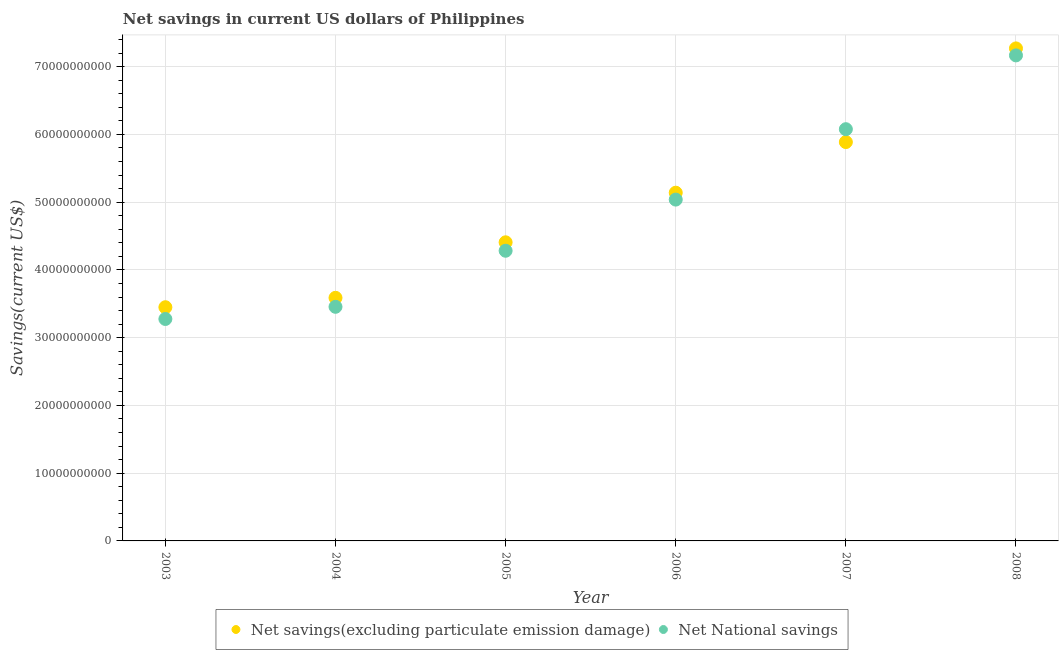How many different coloured dotlines are there?
Your response must be concise. 2. Is the number of dotlines equal to the number of legend labels?
Give a very brief answer. Yes. What is the net savings(excluding particulate emission damage) in 2005?
Provide a short and direct response. 4.41e+1. Across all years, what is the maximum net savings(excluding particulate emission damage)?
Provide a short and direct response. 7.27e+1. Across all years, what is the minimum net savings(excluding particulate emission damage)?
Make the answer very short. 3.45e+1. In which year was the net national savings minimum?
Ensure brevity in your answer.  2003. What is the total net savings(excluding particulate emission damage) in the graph?
Your answer should be compact. 2.97e+11. What is the difference between the net national savings in 2003 and that in 2007?
Provide a short and direct response. -2.80e+1. What is the difference between the net national savings in 2006 and the net savings(excluding particulate emission damage) in 2008?
Ensure brevity in your answer.  -2.23e+1. What is the average net national savings per year?
Offer a terse response. 4.88e+1. In the year 2007, what is the difference between the net national savings and net savings(excluding particulate emission damage)?
Make the answer very short. 1.90e+09. In how many years, is the net savings(excluding particulate emission damage) greater than 14000000000 US$?
Keep it short and to the point. 6. What is the ratio of the net savings(excluding particulate emission damage) in 2005 to that in 2006?
Your answer should be compact. 0.86. Is the difference between the net savings(excluding particulate emission damage) in 2006 and 2008 greater than the difference between the net national savings in 2006 and 2008?
Make the answer very short. No. What is the difference between the highest and the second highest net savings(excluding particulate emission damage)?
Provide a succinct answer. 1.38e+1. What is the difference between the highest and the lowest net savings(excluding particulate emission damage)?
Provide a short and direct response. 3.82e+1. In how many years, is the net savings(excluding particulate emission damage) greater than the average net savings(excluding particulate emission damage) taken over all years?
Your response must be concise. 3. Is the net national savings strictly greater than the net savings(excluding particulate emission damage) over the years?
Your answer should be very brief. No. How many dotlines are there?
Provide a short and direct response. 2. How many years are there in the graph?
Give a very brief answer. 6. What is the difference between two consecutive major ticks on the Y-axis?
Offer a very short reply. 1.00e+1. Where does the legend appear in the graph?
Provide a succinct answer. Bottom center. How are the legend labels stacked?
Provide a short and direct response. Horizontal. What is the title of the graph?
Offer a very short reply. Net savings in current US dollars of Philippines. Does "Public funds" appear as one of the legend labels in the graph?
Your answer should be very brief. No. What is the label or title of the X-axis?
Give a very brief answer. Year. What is the label or title of the Y-axis?
Your answer should be compact. Savings(current US$). What is the Savings(current US$) in Net savings(excluding particulate emission damage) in 2003?
Provide a succinct answer. 3.45e+1. What is the Savings(current US$) in Net National savings in 2003?
Give a very brief answer. 3.28e+1. What is the Savings(current US$) in Net savings(excluding particulate emission damage) in 2004?
Keep it short and to the point. 3.59e+1. What is the Savings(current US$) of Net National savings in 2004?
Give a very brief answer. 3.46e+1. What is the Savings(current US$) of Net savings(excluding particulate emission damage) in 2005?
Your answer should be very brief. 4.41e+1. What is the Savings(current US$) in Net National savings in 2005?
Your answer should be compact. 4.28e+1. What is the Savings(current US$) of Net savings(excluding particulate emission damage) in 2006?
Give a very brief answer. 5.14e+1. What is the Savings(current US$) of Net National savings in 2006?
Your response must be concise. 5.04e+1. What is the Savings(current US$) of Net savings(excluding particulate emission damage) in 2007?
Ensure brevity in your answer.  5.89e+1. What is the Savings(current US$) of Net National savings in 2007?
Keep it short and to the point. 6.08e+1. What is the Savings(current US$) in Net savings(excluding particulate emission damage) in 2008?
Your answer should be very brief. 7.27e+1. What is the Savings(current US$) in Net National savings in 2008?
Offer a very short reply. 7.17e+1. Across all years, what is the maximum Savings(current US$) of Net savings(excluding particulate emission damage)?
Your answer should be compact. 7.27e+1. Across all years, what is the maximum Savings(current US$) in Net National savings?
Your answer should be very brief. 7.17e+1. Across all years, what is the minimum Savings(current US$) of Net savings(excluding particulate emission damage)?
Your response must be concise. 3.45e+1. Across all years, what is the minimum Savings(current US$) of Net National savings?
Make the answer very short. 3.28e+1. What is the total Savings(current US$) of Net savings(excluding particulate emission damage) in the graph?
Offer a terse response. 2.97e+11. What is the total Savings(current US$) in Net National savings in the graph?
Your answer should be compact. 2.93e+11. What is the difference between the Savings(current US$) of Net savings(excluding particulate emission damage) in 2003 and that in 2004?
Offer a very short reply. -1.39e+09. What is the difference between the Savings(current US$) in Net National savings in 2003 and that in 2004?
Offer a terse response. -1.80e+09. What is the difference between the Savings(current US$) of Net savings(excluding particulate emission damage) in 2003 and that in 2005?
Your answer should be compact. -9.58e+09. What is the difference between the Savings(current US$) of Net National savings in 2003 and that in 2005?
Ensure brevity in your answer.  -1.01e+1. What is the difference between the Savings(current US$) in Net savings(excluding particulate emission damage) in 2003 and that in 2006?
Offer a terse response. -1.69e+1. What is the difference between the Savings(current US$) in Net National savings in 2003 and that in 2006?
Offer a terse response. -1.76e+1. What is the difference between the Savings(current US$) of Net savings(excluding particulate emission damage) in 2003 and that in 2007?
Make the answer very short. -2.44e+1. What is the difference between the Savings(current US$) of Net National savings in 2003 and that in 2007?
Your answer should be compact. -2.80e+1. What is the difference between the Savings(current US$) in Net savings(excluding particulate emission damage) in 2003 and that in 2008?
Ensure brevity in your answer.  -3.82e+1. What is the difference between the Savings(current US$) of Net National savings in 2003 and that in 2008?
Ensure brevity in your answer.  -3.89e+1. What is the difference between the Savings(current US$) in Net savings(excluding particulate emission damage) in 2004 and that in 2005?
Your answer should be very brief. -8.19e+09. What is the difference between the Savings(current US$) of Net National savings in 2004 and that in 2005?
Give a very brief answer. -8.27e+09. What is the difference between the Savings(current US$) of Net savings(excluding particulate emission damage) in 2004 and that in 2006?
Offer a very short reply. -1.55e+1. What is the difference between the Savings(current US$) of Net National savings in 2004 and that in 2006?
Ensure brevity in your answer.  -1.58e+1. What is the difference between the Savings(current US$) of Net savings(excluding particulate emission damage) in 2004 and that in 2007?
Ensure brevity in your answer.  -2.30e+1. What is the difference between the Savings(current US$) in Net National savings in 2004 and that in 2007?
Give a very brief answer. -2.62e+1. What is the difference between the Savings(current US$) in Net savings(excluding particulate emission damage) in 2004 and that in 2008?
Give a very brief answer. -3.68e+1. What is the difference between the Savings(current US$) in Net National savings in 2004 and that in 2008?
Your response must be concise. -3.71e+1. What is the difference between the Savings(current US$) in Net savings(excluding particulate emission damage) in 2005 and that in 2006?
Your answer should be compact. -7.32e+09. What is the difference between the Savings(current US$) of Net National savings in 2005 and that in 2006?
Keep it short and to the point. -7.55e+09. What is the difference between the Savings(current US$) in Net savings(excluding particulate emission damage) in 2005 and that in 2007?
Give a very brief answer. -1.48e+1. What is the difference between the Savings(current US$) of Net National savings in 2005 and that in 2007?
Make the answer very short. -1.79e+1. What is the difference between the Savings(current US$) of Net savings(excluding particulate emission damage) in 2005 and that in 2008?
Your answer should be compact. -2.86e+1. What is the difference between the Savings(current US$) of Net National savings in 2005 and that in 2008?
Give a very brief answer. -2.88e+1. What is the difference between the Savings(current US$) in Net savings(excluding particulate emission damage) in 2006 and that in 2007?
Offer a terse response. -7.47e+09. What is the difference between the Savings(current US$) in Net National savings in 2006 and that in 2007?
Keep it short and to the point. -1.04e+1. What is the difference between the Savings(current US$) of Net savings(excluding particulate emission damage) in 2006 and that in 2008?
Give a very brief answer. -2.13e+1. What is the difference between the Savings(current US$) of Net National savings in 2006 and that in 2008?
Your answer should be very brief. -2.13e+1. What is the difference between the Savings(current US$) of Net savings(excluding particulate emission damage) in 2007 and that in 2008?
Your response must be concise. -1.38e+1. What is the difference between the Savings(current US$) in Net National savings in 2007 and that in 2008?
Your response must be concise. -1.09e+1. What is the difference between the Savings(current US$) in Net savings(excluding particulate emission damage) in 2003 and the Savings(current US$) in Net National savings in 2004?
Your response must be concise. -6.26e+07. What is the difference between the Savings(current US$) in Net savings(excluding particulate emission damage) in 2003 and the Savings(current US$) in Net National savings in 2005?
Provide a succinct answer. -8.34e+09. What is the difference between the Savings(current US$) of Net savings(excluding particulate emission damage) in 2003 and the Savings(current US$) of Net National savings in 2006?
Provide a short and direct response. -1.59e+1. What is the difference between the Savings(current US$) of Net savings(excluding particulate emission damage) in 2003 and the Savings(current US$) of Net National savings in 2007?
Give a very brief answer. -2.63e+1. What is the difference between the Savings(current US$) of Net savings(excluding particulate emission damage) in 2003 and the Savings(current US$) of Net National savings in 2008?
Provide a succinct answer. -3.72e+1. What is the difference between the Savings(current US$) of Net savings(excluding particulate emission damage) in 2004 and the Savings(current US$) of Net National savings in 2005?
Offer a terse response. -6.95e+09. What is the difference between the Savings(current US$) of Net savings(excluding particulate emission damage) in 2004 and the Savings(current US$) of Net National savings in 2006?
Your answer should be very brief. -1.45e+1. What is the difference between the Savings(current US$) of Net savings(excluding particulate emission damage) in 2004 and the Savings(current US$) of Net National savings in 2007?
Your response must be concise. -2.49e+1. What is the difference between the Savings(current US$) of Net savings(excluding particulate emission damage) in 2004 and the Savings(current US$) of Net National savings in 2008?
Keep it short and to the point. -3.58e+1. What is the difference between the Savings(current US$) in Net savings(excluding particulate emission damage) in 2005 and the Savings(current US$) in Net National savings in 2006?
Your answer should be compact. -6.30e+09. What is the difference between the Savings(current US$) in Net savings(excluding particulate emission damage) in 2005 and the Savings(current US$) in Net National savings in 2007?
Your answer should be compact. -1.67e+1. What is the difference between the Savings(current US$) of Net savings(excluding particulate emission damage) in 2005 and the Savings(current US$) of Net National savings in 2008?
Your answer should be compact. -2.76e+1. What is the difference between the Savings(current US$) in Net savings(excluding particulate emission damage) in 2006 and the Savings(current US$) in Net National savings in 2007?
Provide a short and direct response. -9.37e+09. What is the difference between the Savings(current US$) in Net savings(excluding particulate emission damage) in 2006 and the Savings(current US$) in Net National savings in 2008?
Keep it short and to the point. -2.03e+1. What is the difference between the Savings(current US$) in Net savings(excluding particulate emission damage) in 2007 and the Savings(current US$) in Net National savings in 2008?
Your answer should be compact. -1.28e+1. What is the average Savings(current US$) of Net savings(excluding particulate emission damage) per year?
Offer a terse response. 4.96e+1. What is the average Savings(current US$) in Net National savings per year?
Give a very brief answer. 4.88e+1. In the year 2003, what is the difference between the Savings(current US$) in Net savings(excluding particulate emission damage) and Savings(current US$) in Net National savings?
Your response must be concise. 1.73e+09. In the year 2004, what is the difference between the Savings(current US$) in Net savings(excluding particulate emission damage) and Savings(current US$) in Net National savings?
Offer a terse response. 1.33e+09. In the year 2005, what is the difference between the Savings(current US$) in Net savings(excluding particulate emission damage) and Savings(current US$) in Net National savings?
Offer a terse response. 1.25e+09. In the year 2006, what is the difference between the Savings(current US$) of Net savings(excluding particulate emission damage) and Savings(current US$) of Net National savings?
Make the answer very short. 1.02e+09. In the year 2007, what is the difference between the Savings(current US$) of Net savings(excluding particulate emission damage) and Savings(current US$) of Net National savings?
Make the answer very short. -1.90e+09. In the year 2008, what is the difference between the Savings(current US$) in Net savings(excluding particulate emission damage) and Savings(current US$) in Net National savings?
Your answer should be compact. 1.03e+09. What is the ratio of the Savings(current US$) of Net savings(excluding particulate emission damage) in 2003 to that in 2004?
Your answer should be compact. 0.96. What is the ratio of the Savings(current US$) in Net National savings in 2003 to that in 2004?
Ensure brevity in your answer.  0.95. What is the ratio of the Savings(current US$) in Net savings(excluding particulate emission damage) in 2003 to that in 2005?
Provide a succinct answer. 0.78. What is the ratio of the Savings(current US$) of Net National savings in 2003 to that in 2005?
Keep it short and to the point. 0.76. What is the ratio of the Savings(current US$) in Net savings(excluding particulate emission damage) in 2003 to that in 2006?
Give a very brief answer. 0.67. What is the ratio of the Savings(current US$) in Net National savings in 2003 to that in 2006?
Provide a short and direct response. 0.65. What is the ratio of the Savings(current US$) in Net savings(excluding particulate emission damage) in 2003 to that in 2007?
Provide a succinct answer. 0.59. What is the ratio of the Savings(current US$) in Net National savings in 2003 to that in 2007?
Your response must be concise. 0.54. What is the ratio of the Savings(current US$) of Net savings(excluding particulate emission damage) in 2003 to that in 2008?
Keep it short and to the point. 0.47. What is the ratio of the Savings(current US$) of Net National savings in 2003 to that in 2008?
Keep it short and to the point. 0.46. What is the ratio of the Savings(current US$) in Net savings(excluding particulate emission damage) in 2004 to that in 2005?
Provide a succinct answer. 0.81. What is the ratio of the Savings(current US$) in Net National savings in 2004 to that in 2005?
Offer a terse response. 0.81. What is the ratio of the Savings(current US$) of Net savings(excluding particulate emission damage) in 2004 to that in 2006?
Your answer should be compact. 0.7. What is the ratio of the Savings(current US$) of Net National savings in 2004 to that in 2006?
Ensure brevity in your answer.  0.69. What is the ratio of the Savings(current US$) of Net savings(excluding particulate emission damage) in 2004 to that in 2007?
Give a very brief answer. 0.61. What is the ratio of the Savings(current US$) of Net National savings in 2004 to that in 2007?
Keep it short and to the point. 0.57. What is the ratio of the Savings(current US$) of Net savings(excluding particulate emission damage) in 2004 to that in 2008?
Provide a succinct answer. 0.49. What is the ratio of the Savings(current US$) of Net National savings in 2004 to that in 2008?
Your answer should be very brief. 0.48. What is the ratio of the Savings(current US$) in Net savings(excluding particulate emission damage) in 2005 to that in 2006?
Provide a short and direct response. 0.86. What is the ratio of the Savings(current US$) in Net National savings in 2005 to that in 2006?
Provide a succinct answer. 0.85. What is the ratio of the Savings(current US$) in Net savings(excluding particulate emission damage) in 2005 to that in 2007?
Your response must be concise. 0.75. What is the ratio of the Savings(current US$) of Net National savings in 2005 to that in 2007?
Offer a terse response. 0.7. What is the ratio of the Savings(current US$) of Net savings(excluding particulate emission damage) in 2005 to that in 2008?
Your response must be concise. 0.61. What is the ratio of the Savings(current US$) in Net National savings in 2005 to that in 2008?
Your answer should be compact. 0.6. What is the ratio of the Savings(current US$) in Net savings(excluding particulate emission damage) in 2006 to that in 2007?
Give a very brief answer. 0.87. What is the ratio of the Savings(current US$) of Net National savings in 2006 to that in 2007?
Offer a terse response. 0.83. What is the ratio of the Savings(current US$) of Net savings(excluding particulate emission damage) in 2006 to that in 2008?
Offer a terse response. 0.71. What is the ratio of the Savings(current US$) in Net National savings in 2006 to that in 2008?
Your response must be concise. 0.7. What is the ratio of the Savings(current US$) of Net savings(excluding particulate emission damage) in 2007 to that in 2008?
Offer a terse response. 0.81. What is the ratio of the Savings(current US$) in Net National savings in 2007 to that in 2008?
Keep it short and to the point. 0.85. What is the difference between the highest and the second highest Savings(current US$) of Net savings(excluding particulate emission damage)?
Provide a short and direct response. 1.38e+1. What is the difference between the highest and the second highest Savings(current US$) in Net National savings?
Give a very brief answer. 1.09e+1. What is the difference between the highest and the lowest Savings(current US$) in Net savings(excluding particulate emission damage)?
Keep it short and to the point. 3.82e+1. What is the difference between the highest and the lowest Savings(current US$) in Net National savings?
Offer a terse response. 3.89e+1. 